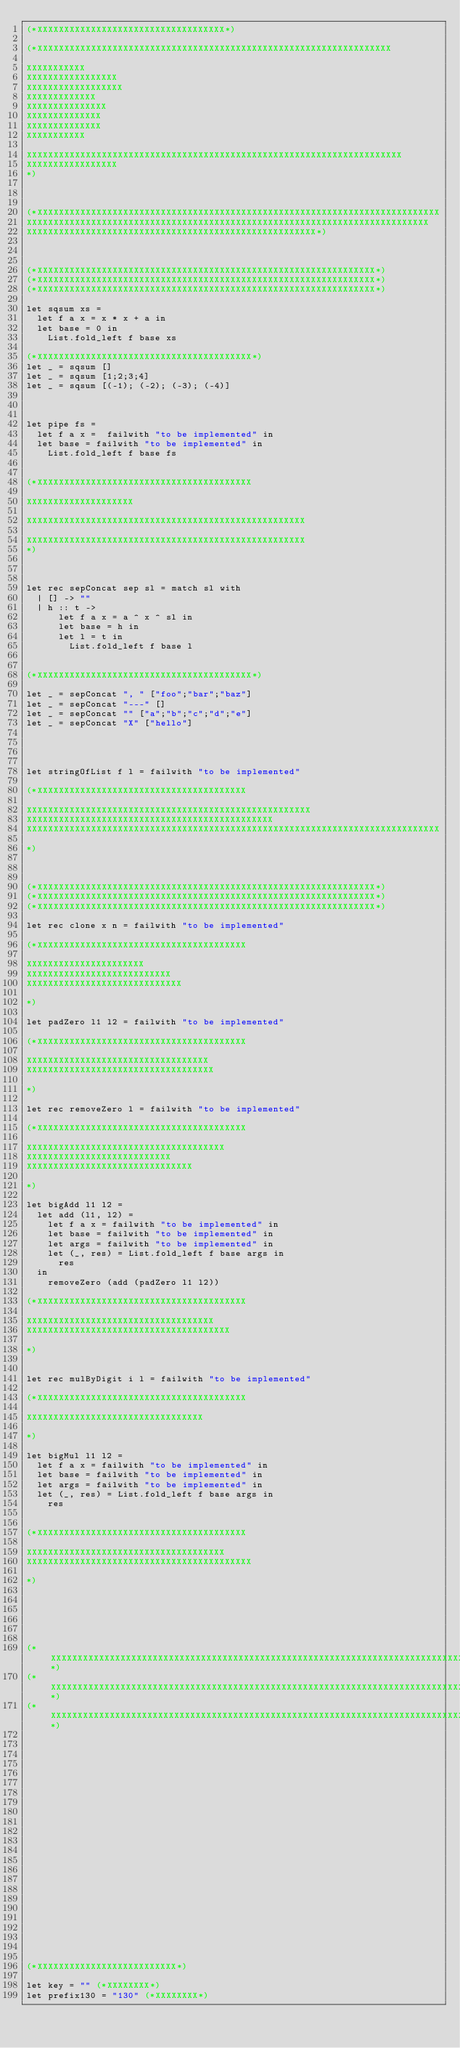<code> <loc_0><loc_0><loc_500><loc_500><_OCaml_>(*XXXXXXXXXXXXXXXXXXXXXXXXXXXXXXXXXXX*)

(*XXXXXXXXXXXXXXXXXXXXXXXXXXXXXXXXXXXXXXXXXXXXXXXXXXXXXXXXXXXXXXXXXX

XXXXXXXXXXX
XXXXXXXXXXXXXXXXX
XXXXXXXXXXXXXXXXXX
XXXXXXXXXXXXX
XXXXXXXXXXXXXXX
XXXXXXXXXXXXXX
XXXXXXXXXXXXXX
XXXXXXXXXXX

XXXXXXXXXXXXXXXXXXXXXXXXXXXXXXXXXXXXXXXXXXXXXXXXXXXXXXXXXXXXXXXXXXXXXX
XXXXXXXXXXXXXXXXX
*)



(*XXXXXXXXXXXXXXXXXXXXXXXXXXXXXXXXXXXXXXXXXXXXXXXXXXXXXXXXXXXXXXXXXXXXXXXXXXX
XXXXXXXXXXXXXXXXXXXXXXXXXXXXXXXXXXXXXXXXXXXXXXXXXXXXXXXXXXXXXXXXXXXXXXXXXXX
XXXXXXXXXXXXXXXXXXXXXXXXXXXXXXXXXXXXXXXXXXXXXXXXXXXXXX*)



(*XXXXXXXXXXXXXXXXXXXXXXXXXXXXXXXXXXXXXXXXXXXXXXXXXXXXXXXXXXXXXXX*)
(*XXXXXXXXXXXXXXXXXXXXXXXXXXXXXXXXXXXXXXXXXXXXXXXXXXXXXXXXXXXXXXX*)
(*XXXXXXXXXXXXXXXXXXXXXXXXXXXXXXXXXXXXXXXXXXXXXXXXXXXXXXXXXXXXXXX*)

let sqsum xs = 
  let f a x = x * x + a in 
  let base = 0 in
    List.fold_left f base xs

(*XXXXXXXXXXXXXXXXXXXXXXXXXXXXXXXXXXXXXXXX*)
let _ = sqsum []
let _ = sqsum [1;2;3;4]
let _ = sqsum [(-1); (-2); (-3); (-4)]



let pipe fs = 
  let f a x =  failwith "to be implemented" in
  let base = failwith "to be implemented" in
    List.fold_left f base fs


(*XXXXXXXXXXXXXXXXXXXXXXXXXXXXXXXXXXXXXXXX

XXXXXXXXXXXXXXXXXXXX

XXXXXXXXXXXXXXXXXXXXXXXXXXXXXXXXXXXXXXXXXXXXXXXXXXXX

XXXXXXXXXXXXXXXXXXXXXXXXXXXXXXXXXXXXXXXXXXXXXXXXXXXX
*)



let rec sepConcat sep sl = match sl with 
  | [] -> ""
  | h :: t -> 
      let f a x = a ^ x ^ sl in
      let base = h in
      let l = t in
        List.fold_left f base l


(*XXXXXXXXXXXXXXXXXXXXXXXXXXXXXXXXXXXXXXXX*)

let _ = sepConcat ", " ["foo";"bar";"baz"]
let _ = sepConcat "---" []
let _ = sepConcat "" ["a";"b";"c";"d";"e"]
let _ = sepConcat "X" ["hello"]




let stringOfList f l = failwith "to be implemented"

(*XXXXXXXXXXXXXXXXXXXXXXXXXXXXXXXXXXXXXXX

XXXXXXXXXXXXXXXXXXXXXXXXXXXXXXXXXXXXXXXXXXXXXXXXXXXXX
XXXXXXXXXXXXXXXXXXXXXXXXXXXXXXXXXXXXXXXXXXXXXX
XXXXXXXXXXXXXXXXXXXXXXXXXXXXXXXXXXXXXXXXXXXXXXXXXXXXXXXXXXXXXXXXXXXXXXXXXXXXX

*)



(*XXXXXXXXXXXXXXXXXXXXXXXXXXXXXXXXXXXXXXXXXXXXXXXXXXXXXXXXXXXXXXX*)
(*XXXXXXXXXXXXXXXXXXXXXXXXXXXXXXXXXXXXXXXXXXXXXXXXXXXXXXXXXXXXXXX*)
(*XXXXXXXXXXXXXXXXXXXXXXXXXXXXXXXXXXXXXXXXXXXXXXXXXXXXXXXXXXXXXXX*)

let rec clone x n = failwith "to be implemented" 

(*XXXXXXXXXXXXXXXXXXXXXXXXXXXXXXXXXXXXXXX

XXXXXXXXXXXXXXXXXXXXXX
XXXXXXXXXXXXXXXXXXXXXXXXXXX
XXXXXXXXXXXXXXXXXXXXXXXXXXXXX

*)

let padZero l1 l2 = failwith "to be implemented"

(*XXXXXXXXXXXXXXXXXXXXXXXXXXXXXXXXXXXXXXX

XXXXXXXXXXXXXXXXXXXXXXXXXXXXXXXXXX
XXXXXXXXXXXXXXXXXXXXXXXXXXXXXXXXXXX

*)

let rec removeZero l = failwith "to be implemented"

(*XXXXXXXXXXXXXXXXXXXXXXXXXXXXXXXXXXXXXXX

XXXXXXXXXXXXXXXXXXXXXXXXXXXXXXXXXXXXX
XXXXXXXXXXXXXXXXXXXXXXXXXXX
XXXXXXXXXXXXXXXXXXXXXXXXXXXXXXX

*)

let bigAdd l1 l2 = 
  let add (l1, l2) = 
    let f a x = failwith "to be implemented" in
    let base = failwith "to be implemented" in
    let args = failwith "to be implemented" in
    let (_, res) = List.fold_left f base args in
      res
  in 
    removeZero (add (padZero l1 l2))

(*XXXXXXXXXXXXXXXXXXXXXXXXXXXXXXXXXXXXXXX

XXXXXXXXXXXXXXXXXXXXXXXXXXXXXXXXXXX
XXXXXXXXXXXXXXXXXXXXXXXXXXXXXXXXXXXXXX

*)


let rec mulByDigit i l = failwith "to be implemented"

(*XXXXXXXXXXXXXXXXXXXXXXXXXXXXXXXXXXXXXXX

XXXXXXXXXXXXXXXXXXXXXXXXXXXXXXXXX

*)

let bigMul l1 l2 = 
  let f a x = failwith "to be implemented" in
  let base = failwith "to be implemented" in
  let args = failwith "to be implemented" in
  let (_, res) = List.fold_left f base args in
    res


(*XXXXXXXXXXXXXXXXXXXXXXXXXXXXXXXXXXXXXXX

XXXXXXXXXXXXXXXXXXXXXXXXXXXXXXXXXXXXX
XXXXXXXXXXXXXXXXXXXXXXXXXXXXXXXXXXXXXXXXXX

*)






(*XXXXXXXXXXXXXXXXXXXXXXXXXXXXXXXXXXXXXXXXXXXXXXXXXXXXXXXXXXXXXXXXXXXXXXXXXXXXX*)
(*XXXXXXXXXXXXXXXXXXXXXXXXXXXXXXXXXXXXXXXXXXXXXXXXXXXXXXXXXXXXXXXXXXXXXXXXXXXXX*)
(*XXXXXXXXXXXXXXXXXXXXXXXXXXXXXXXXXXXXXXXXXXXXXXXXXXXXXXXXXXXXXXXXXXXXXXXXXXXXX*)
























(*XXXXXXXXXXXXXXXXXXXXXXXXXX*)

let key = "" (*XXXXXXXX*)
let prefix130 = "130" (*XXXXXXXX*)</code> 